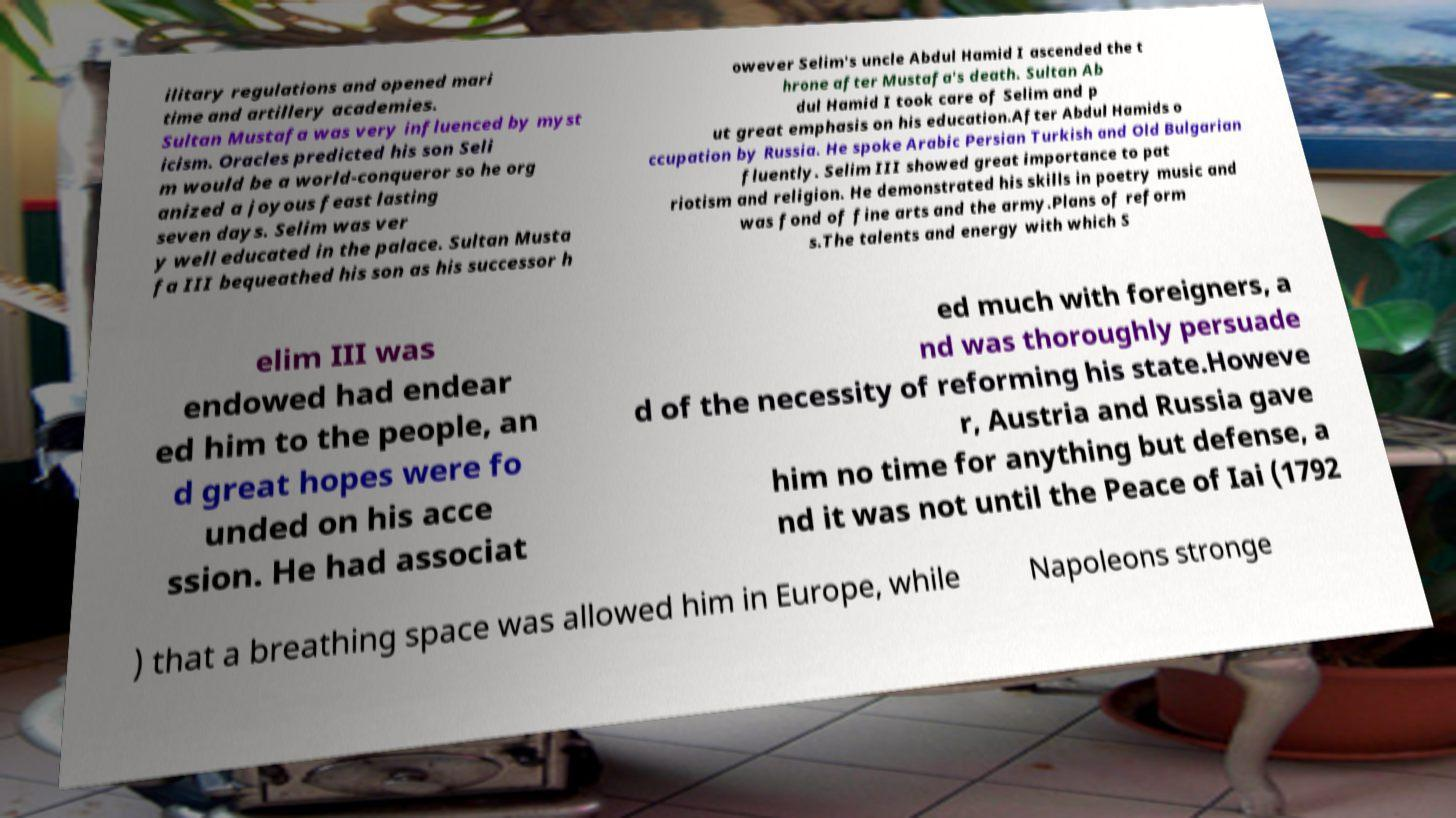There's text embedded in this image that I need extracted. Can you transcribe it verbatim? ilitary regulations and opened mari time and artillery academies. Sultan Mustafa was very influenced by myst icism. Oracles predicted his son Seli m would be a world-conqueror so he org anized a joyous feast lasting seven days. Selim was ver y well educated in the palace. Sultan Musta fa III bequeathed his son as his successor h owever Selim's uncle Abdul Hamid I ascended the t hrone after Mustafa's death. Sultan Ab dul Hamid I took care of Selim and p ut great emphasis on his education.After Abdul Hamids o ccupation by Russia. He spoke Arabic Persian Turkish and Old Bulgarian fluently. Selim III showed great importance to pat riotism and religion. He demonstrated his skills in poetry music and was fond of fine arts and the army.Plans of reform s.The talents and energy with which S elim III was endowed had endear ed him to the people, an d great hopes were fo unded on his acce ssion. He had associat ed much with foreigners, a nd was thoroughly persuade d of the necessity of reforming his state.Howeve r, Austria and Russia gave him no time for anything but defense, a nd it was not until the Peace of Iai (1792 ) that a breathing space was allowed him in Europe, while Napoleons stronge 